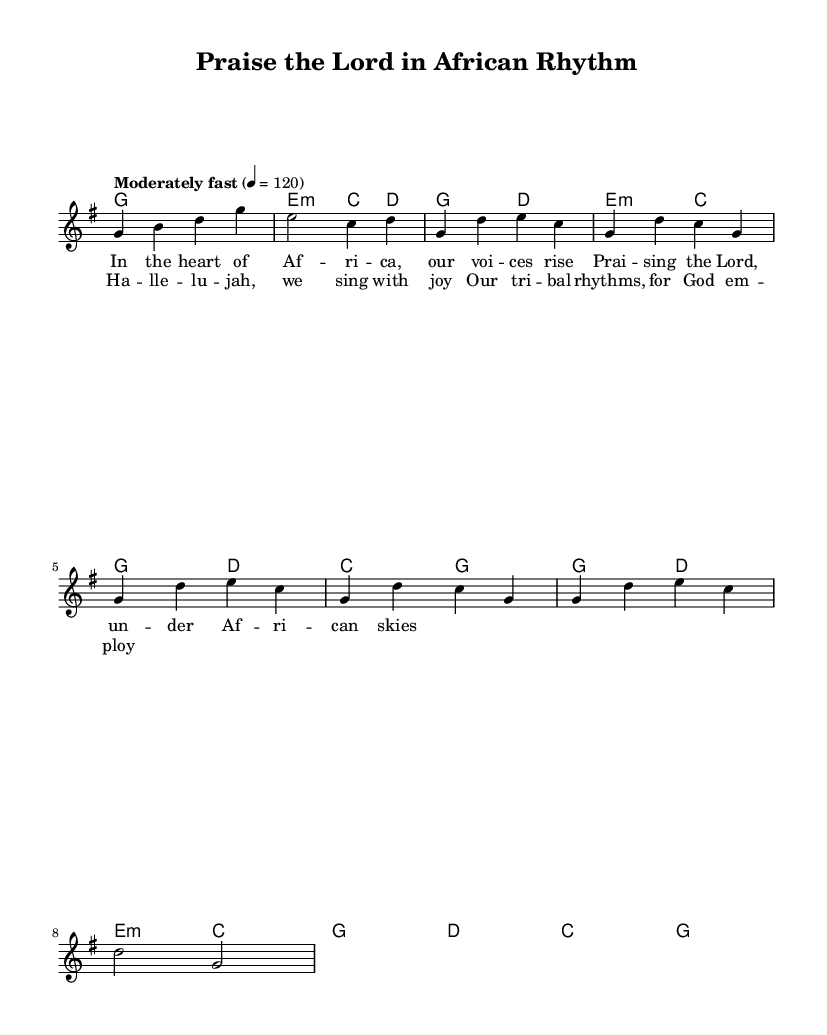What is the key signature of this music? The key signature is indicated by the presence of one sharp on the staff, which corresponds to G major.
Answer: G major What is the time signature of this piece? The time signature is shown as 4/4, which means there are four beats in each measure.
Answer: 4/4 What is the tempo marking for this music? The tempo marking provided at the beginning indicates a moderately fast pace of 120 beats per minute.
Answer: Moderately fast How many measures are in the chorus section? By counting the measures in the chorus part from the sheet music, there are four measures that make up the chorus.
Answer: 4 Identify the first note of the verse. The first note in the verse section is G, which is clearly shown in the melody line.
Answer: G What is the key theme presented in the lyrics? The key theme in the lyrics is the act of praising the Lord, set against an African cultural backdrop represented through tribal rhythms.
Answer: Praising the Lord How does the harmony change between the verse and chorus? The harmony transitions from a G major and E minor combination in the verse to repeating similar chord patterns in the chorus, creating a harmonic continuity while emphasizing rhythm.
Answer: Similar chord patterns 